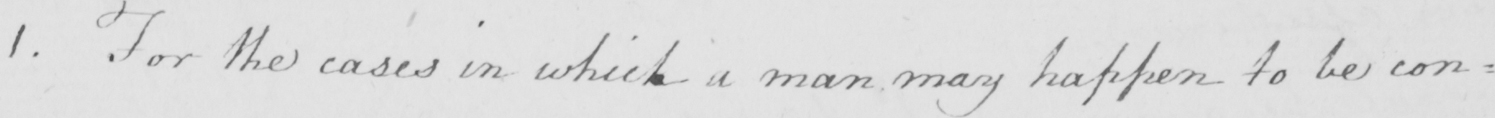What does this handwritten line say? 1. For the cases in which a man may happen to be con= 